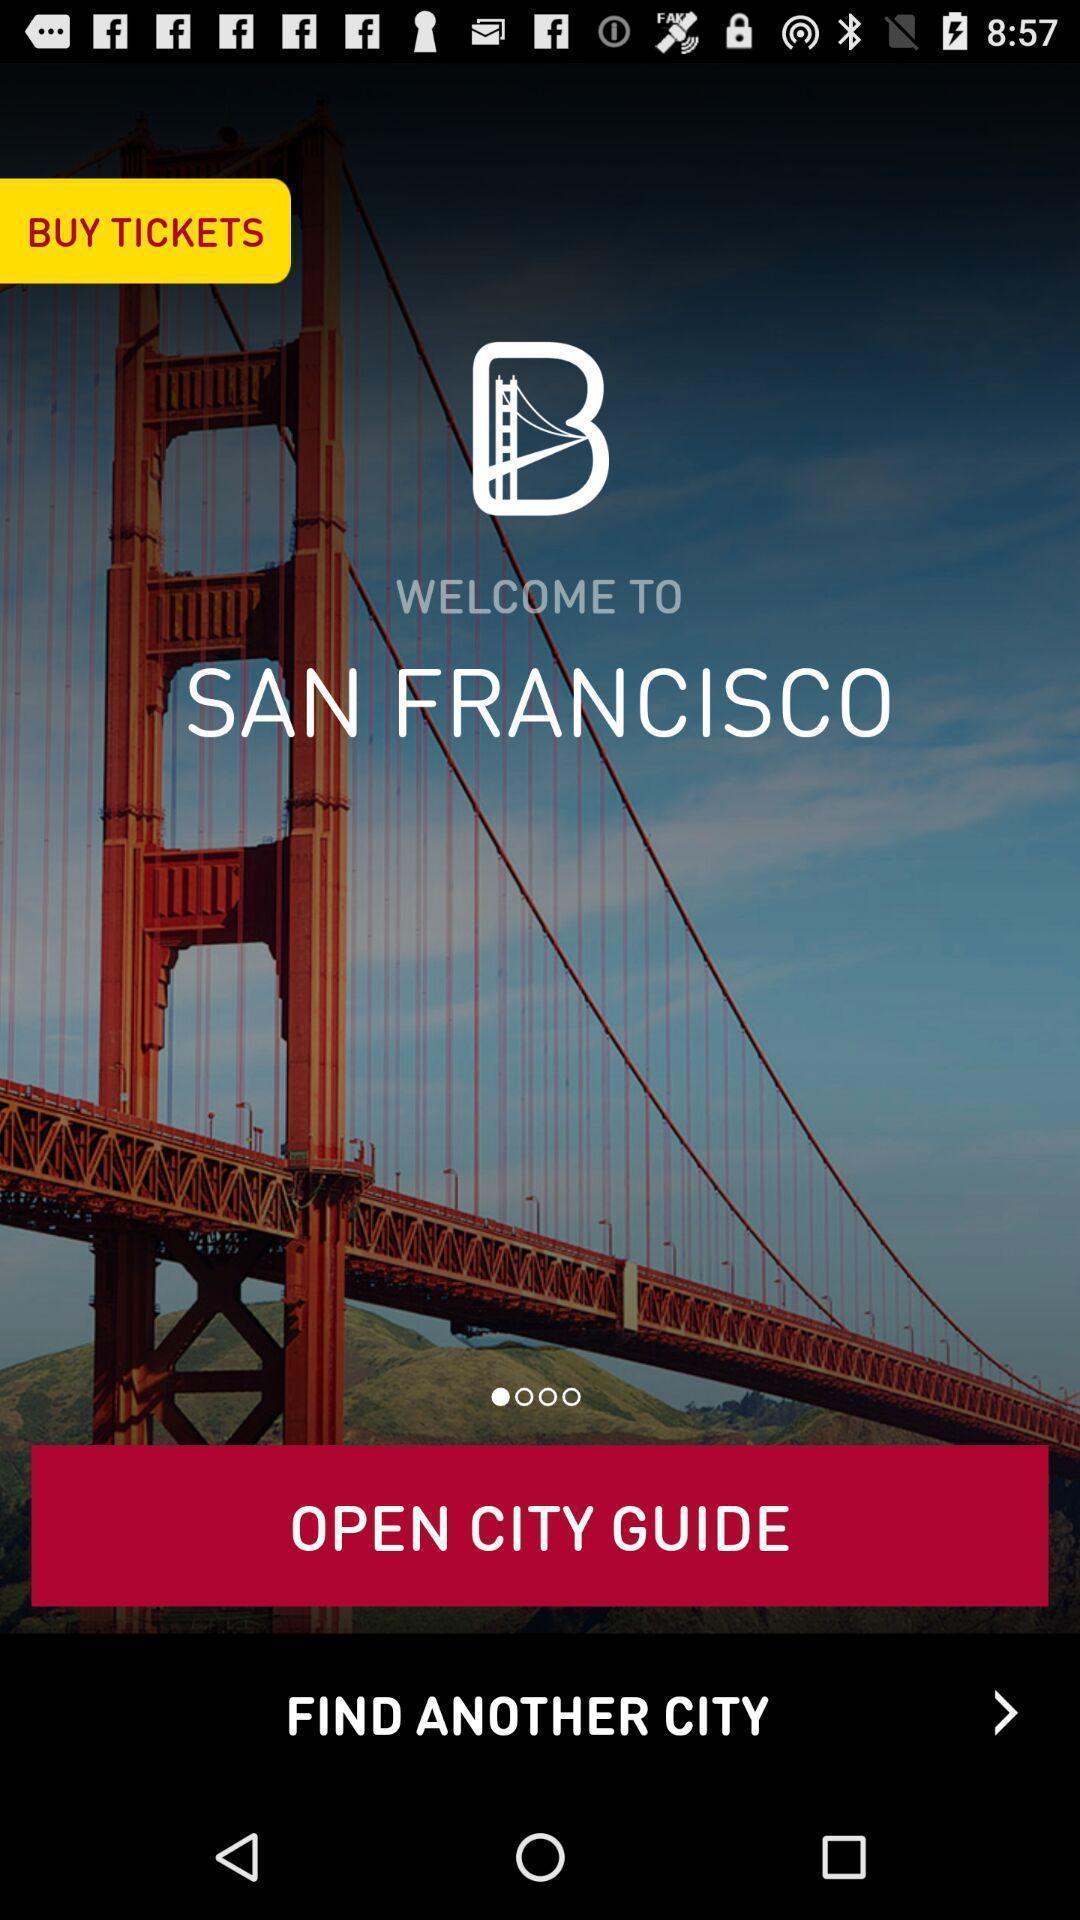Describe the content in this image. Welcome page. 